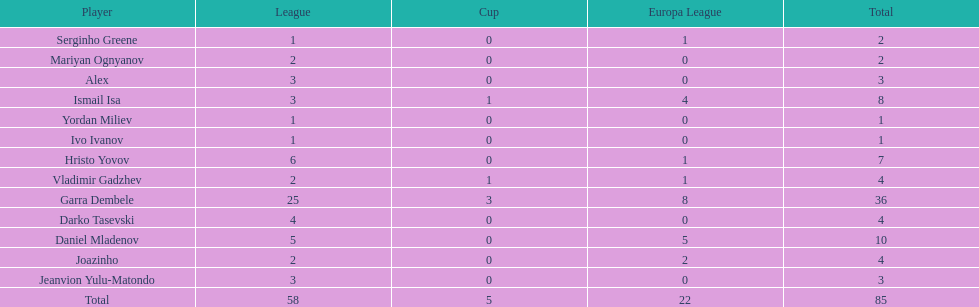How many players did not score a goal in cup play? 10. 